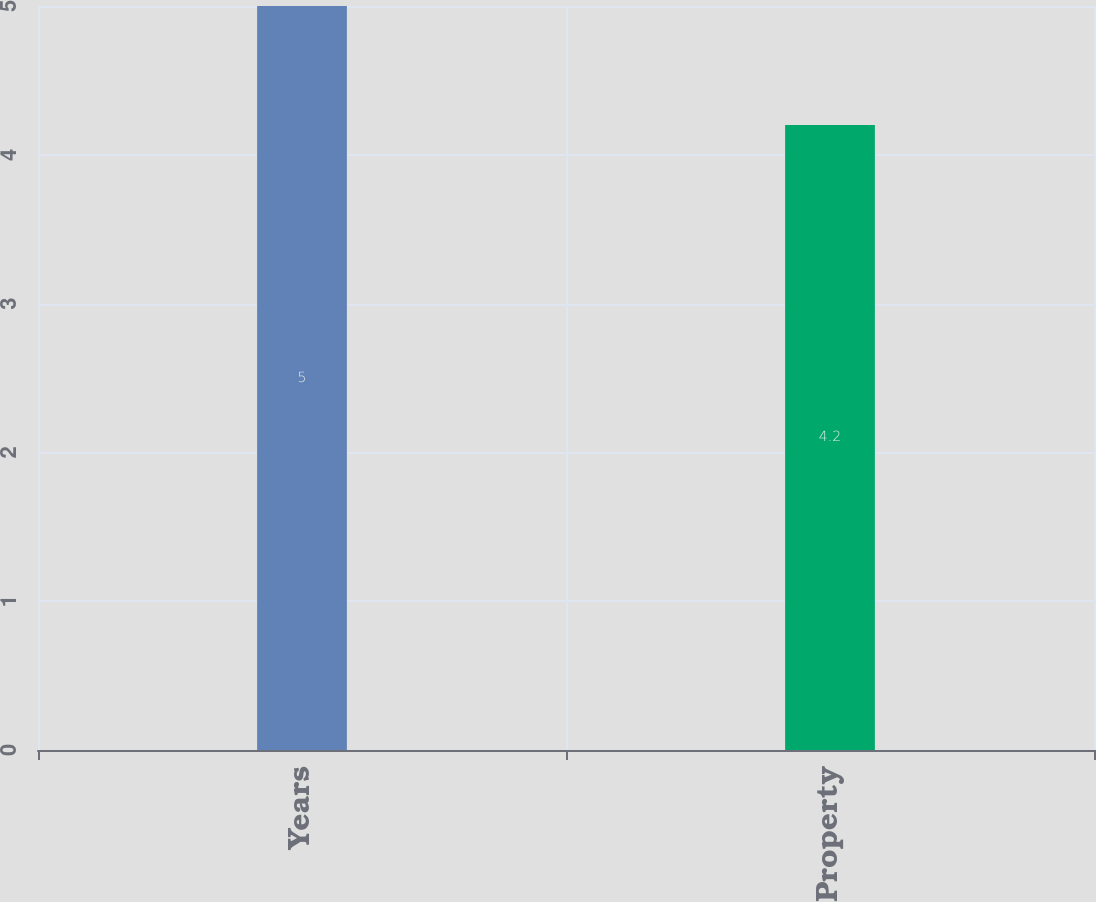Convert chart. <chart><loc_0><loc_0><loc_500><loc_500><bar_chart><fcel>Years<fcel>Property<nl><fcel>5<fcel>4.2<nl></chart> 